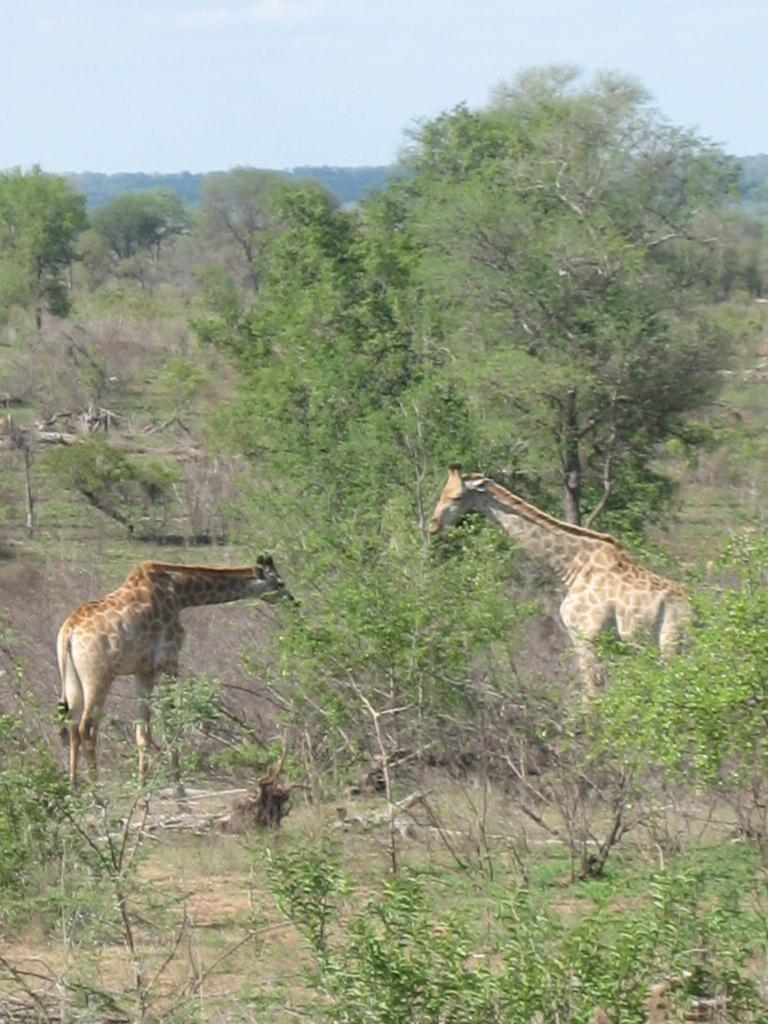What animals can be seen in the image? There are giraffes in the image. What type of vegetation is present in the image? There are trees in the image. What can be seen in the background of the image? The sky is visible in the background of the image. Can you tell me what type of camera the girl is using to take a picture of the actor in the image? There is no girl, camera, or actor present in the image; it features giraffes and trees. 